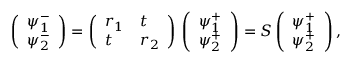Convert formula to latex. <formula><loc_0><loc_0><loc_500><loc_500>\left ( \begin{array} { l } { \psi _ { 1 } ^ { - } } \\ { \psi _ { 2 } ^ { - } } \end{array} \right ) = \left ( \begin{array} { l l } { r _ { 1 } } & { t } \\ { t } & { r _ { 2 } } \end{array} \right ) \, \left ( \begin{array} { l } { \psi _ { 1 } ^ { + } } \\ { \psi _ { 2 } ^ { + } } \end{array} \right ) = S \left ( \begin{array} { l } { \psi _ { 1 } ^ { + } } \\ { \psi _ { 2 } ^ { + } } \end{array} \right ) ,</formula> 